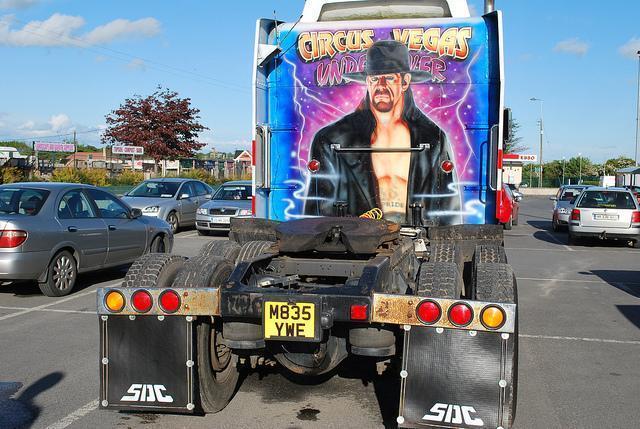How many cars are in the photo?
Give a very brief answer. 4. How many banana stems without bananas are there?
Give a very brief answer. 0. 